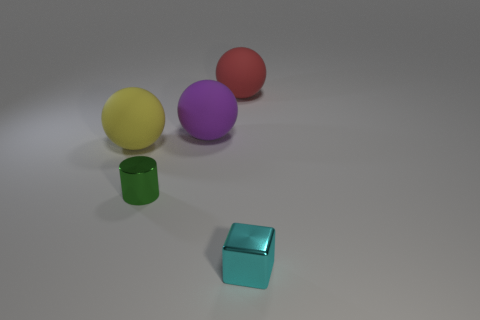There is a rubber thing that is behind the big yellow rubber ball and in front of the big red object; how big is it?
Your response must be concise. Large. There is a red rubber object that is the same shape as the large purple thing; what size is it?
Ensure brevity in your answer.  Large. What number of things are large brown rubber balls or small objects behind the small metal block?
Make the answer very short. 1. What is the shape of the large yellow thing?
Offer a terse response. Sphere. The small shiny thing right of the big ball behind the purple thing is what shape?
Your answer should be compact. Cube. There is another object that is made of the same material as the tiny cyan object; what color is it?
Your response must be concise. Green. Is there anything else that has the same size as the block?
Ensure brevity in your answer.  Yes. Do the small object that is to the left of the cyan shiny cube and the matte ball that is on the left side of the metallic cylinder have the same color?
Offer a very short reply. No. Are there more big yellow objects to the right of the cyan metallic cube than purple objects that are in front of the green thing?
Your response must be concise. No. Are there any other things that are the same shape as the large red rubber object?
Make the answer very short. Yes. 